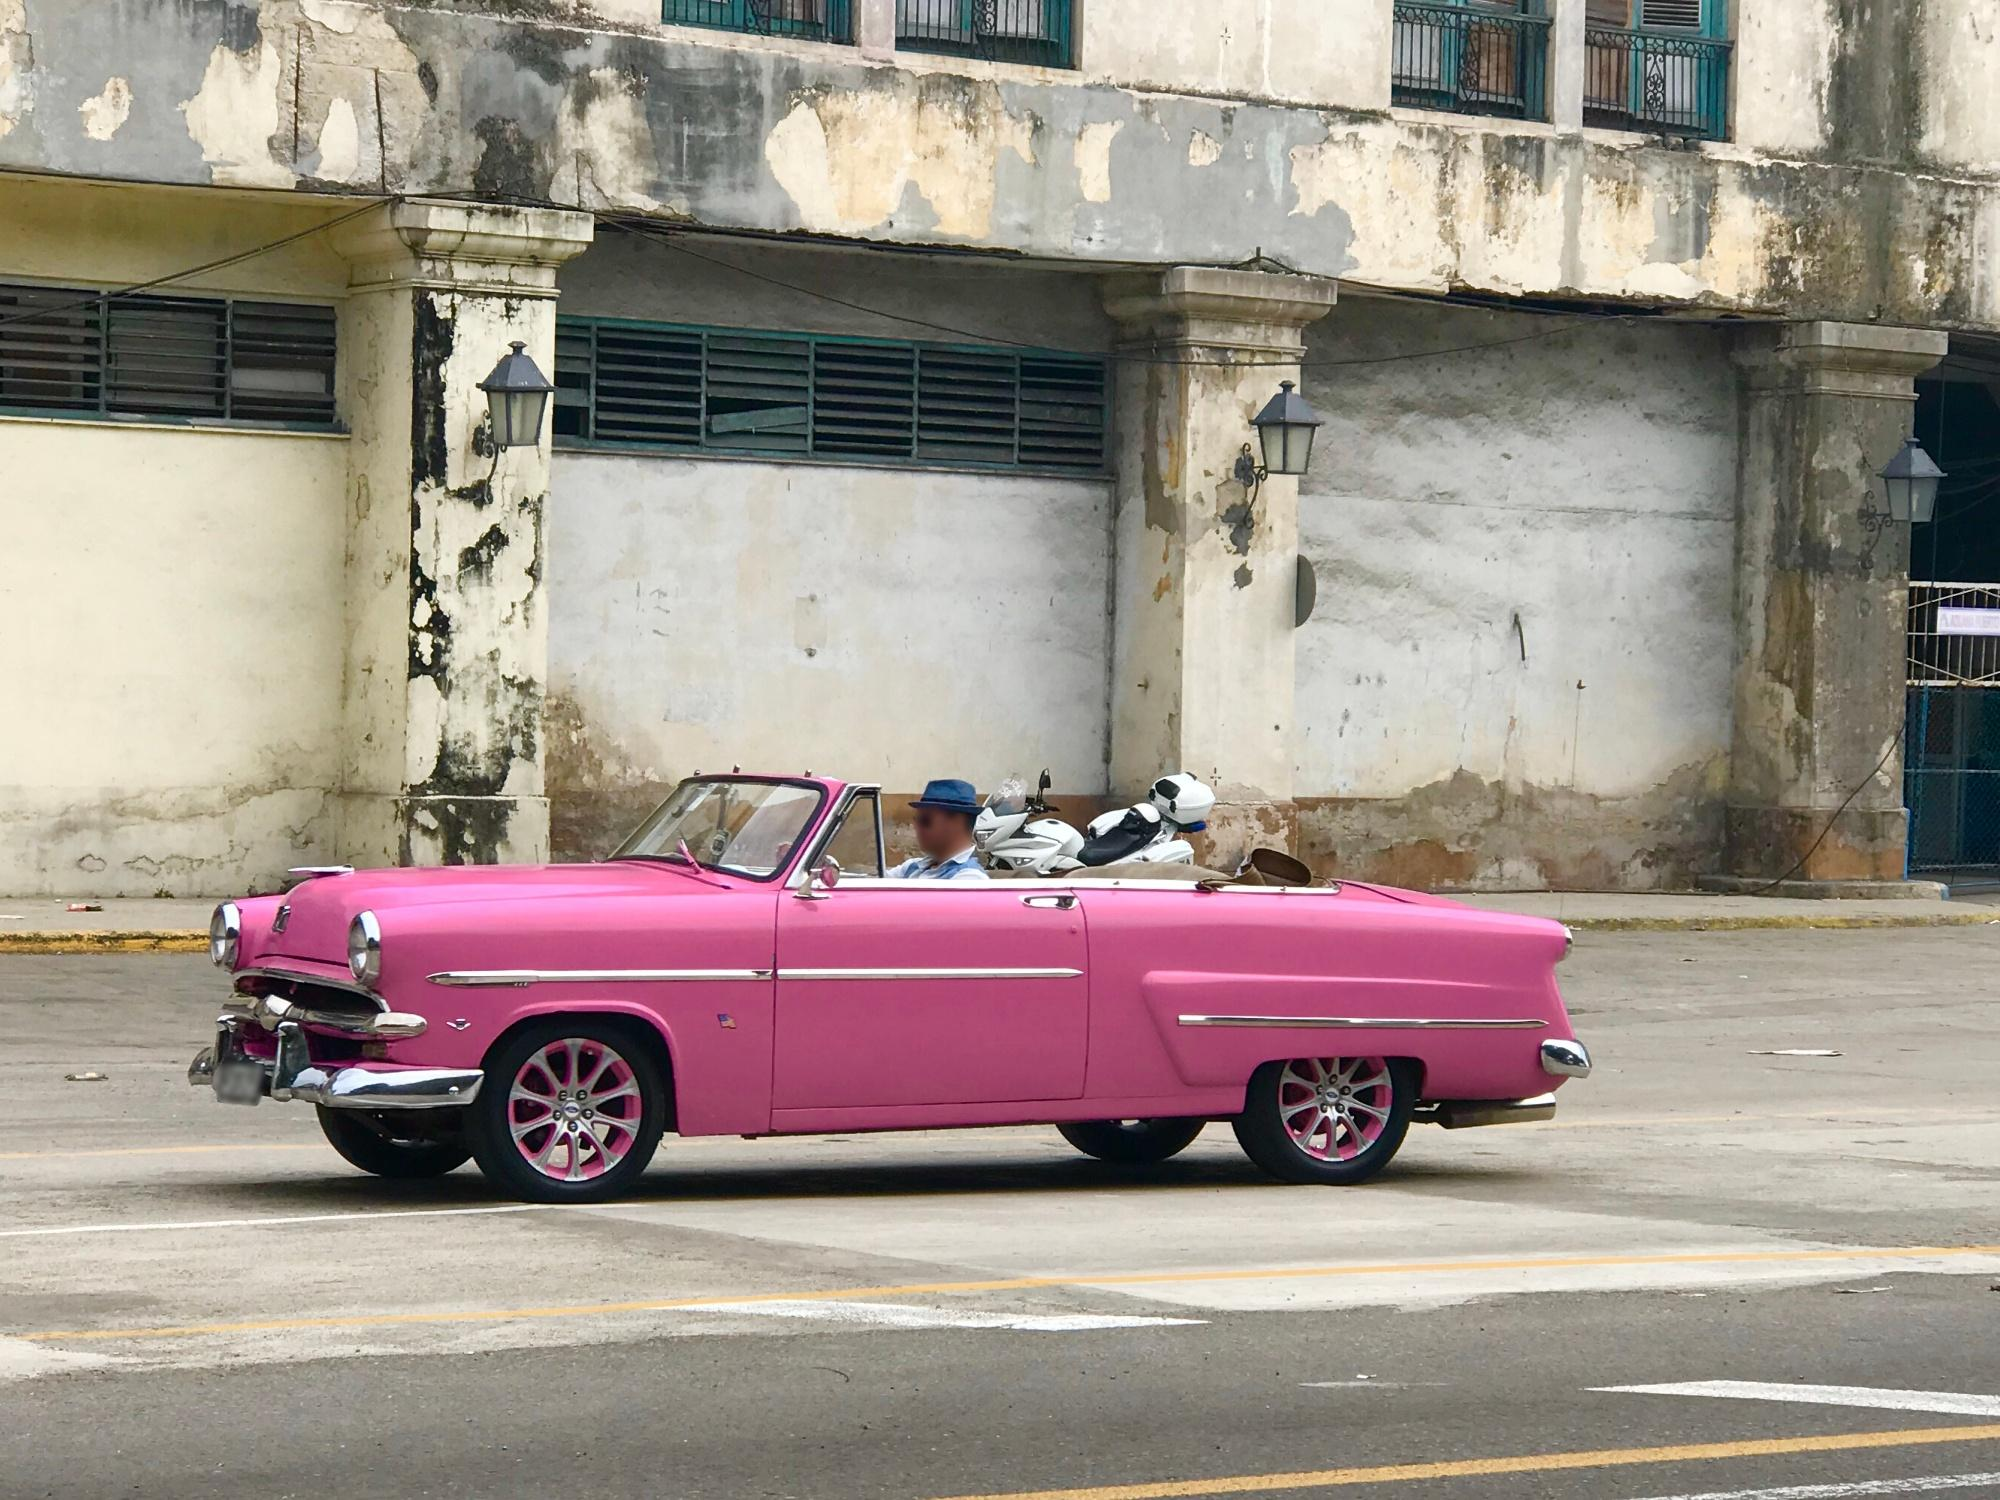Imagine a story about a day in the life of the car's driver in this setting. In the early morning, the car's owner, a local vintage car restorer, polishes the pink convertible before setting off through the town’s quiet streets. As he drives, he waves to neighbors and fellow car enthusiasts who admire the car's pristine condition. His journey is both a personal escape and a public display, intertwining his love for car restoration with his desire to bring vibrancy back to his community. Despite the evident decay of the urban landscape, the car brings a sense of hope and color, inspiring those who see it to remember the area's brighter days and imagine what could be yet to come. 